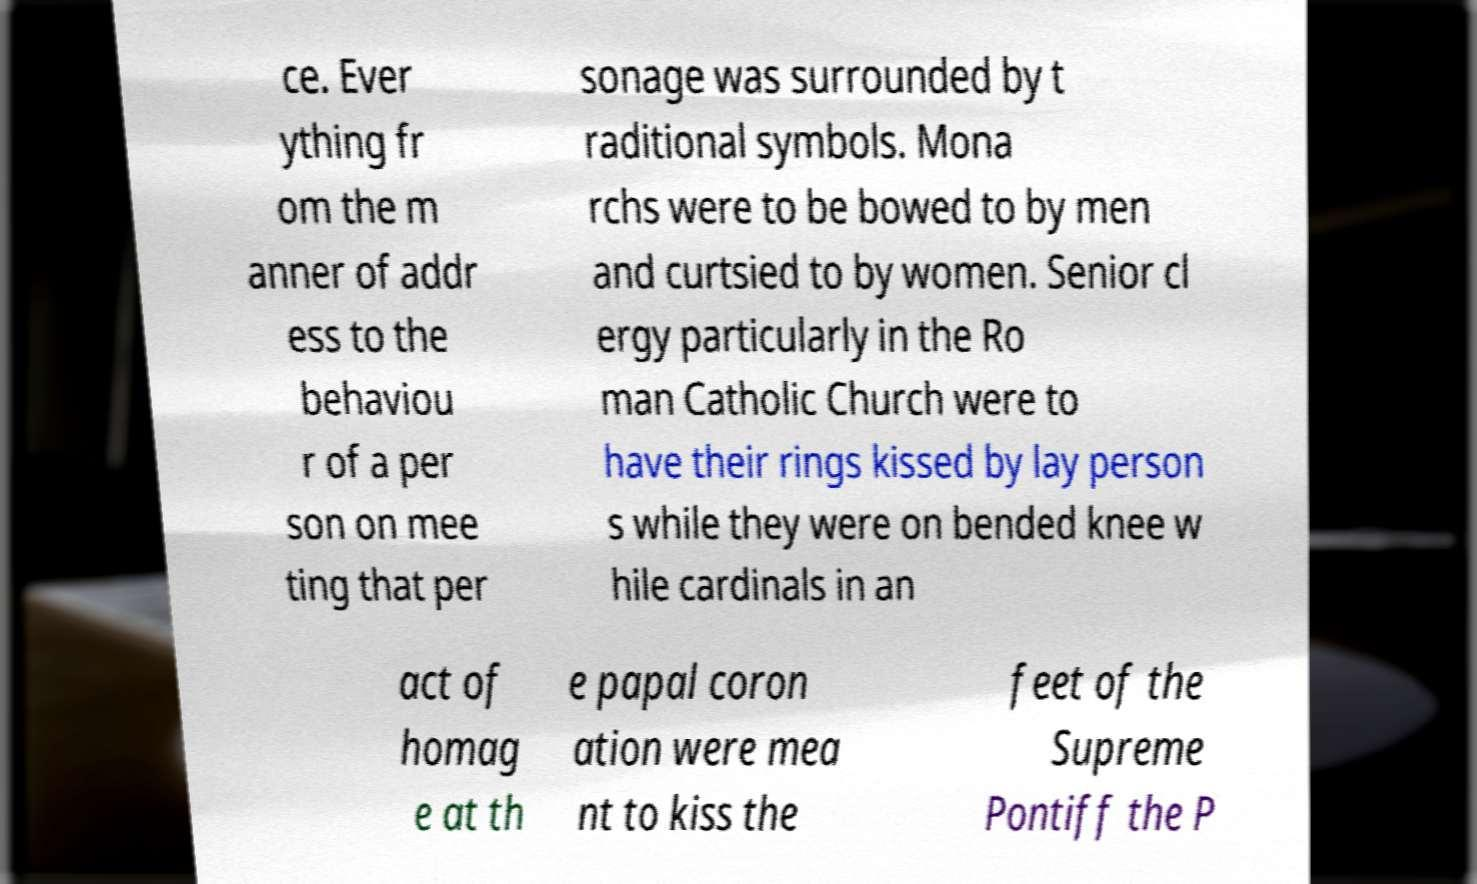Can you accurately transcribe the text from the provided image for me? ce. Ever ything fr om the m anner of addr ess to the behaviou r of a per son on mee ting that per sonage was surrounded by t raditional symbols. Mona rchs were to be bowed to by men and curtsied to by women. Senior cl ergy particularly in the Ro man Catholic Church were to have their rings kissed by lay person s while they were on bended knee w hile cardinals in an act of homag e at th e papal coron ation were mea nt to kiss the feet of the Supreme Pontiff the P 